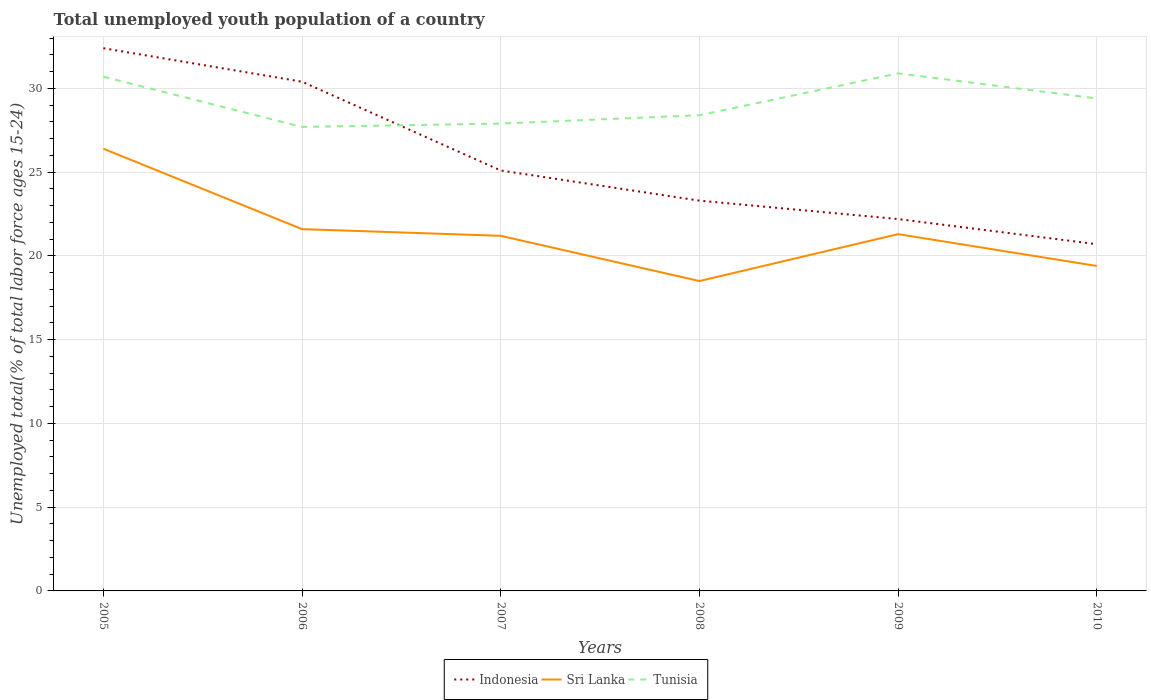Is the number of lines equal to the number of legend labels?
Offer a terse response. Yes. Across all years, what is the maximum percentage of total unemployed youth population of a country in Indonesia?
Keep it short and to the point. 20.7. In which year was the percentage of total unemployed youth population of a country in Sri Lanka maximum?
Offer a very short reply. 2008. What is the total percentage of total unemployed youth population of a country in Sri Lanka in the graph?
Give a very brief answer. 1.9. What is the difference between the highest and the second highest percentage of total unemployed youth population of a country in Sri Lanka?
Your response must be concise. 7.9. What is the difference between the highest and the lowest percentage of total unemployed youth population of a country in Indonesia?
Your response must be concise. 2. How many years are there in the graph?
Provide a succinct answer. 6. Are the values on the major ticks of Y-axis written in scientific E-notation?
Your answer should be compact. No. Does the graph contain any zero values?
Make the answer very short. No. Does the graph contain grids?
Provide a short and direct response. Yes. How many legend labels are there?
Your answer should be very brief. 3. How are the legend labels stacked?
Make the answer very short. Horizontal. What is the title of the graph?
Your response must be concise. Total unemployed youth population of a country. What is the label or title of the X-axis?
Make the answer very short. Years. What is the label or title of the Y-axis?
Your answer should be compact. Unemployed total(% of total labor force ages 15-24). What is the Unemployed total(% of total labor force ages 15-24) of Indonesia in 2005?
Make the answer very short. 32.4. What is the Unemployed total(% of total labor force ages 15-24) in Sri Lanka in 2005?
Give a very brief answer. 26.4. What is the Unemployed total(% of total labor force ages 15-24) in Tunisia in 2005?
Offer a terse response. 30.7. What is the Unemployed total(% of total labor force ages 15-24) in Indonesia in 2006?
Offer a terse response. 30.4. What is the Unemployed total(% of total labor force ages 15-24) in Sri Lanka in 2006?
Provide a succinct answer. 21.6. What is the Unemployed total(% of total labor force ages 15-24) in Tunisia in 2006?
Make the answer very short. 27.7. What is the Unemployed total(% of total labor force ages 15-24) in Indonesia in 2007?
Offer a terse response. 25.1. What is the Unemployed total(% of total labor force ages 15-24) of Sri Lanka in 2007?
Provide a succinct answer. 21.2. What is the Unemployed total(% of total labor force ages 15-24) in Tunisia in 2007?
Your answer should be very brief. 27.9. What is the Unemployed total(% of total labor force ages 15-24) in Indonesia in 2008?
Offer a very short reply. 23.3. What is the Unemployed total(% of total labor force ages 15-24) in Sri Lanka in 2008?
Make the answer very short. 18.5. What is the Unemployed total(% of total labor force ages 15-24) in Tunisia in 2008?
Give a very brief answer. 28.4. What is the Unemployed total(% of total labor force ages 15-24) of Indonesia in 2009?
Give a very brief answer. 22.2. What is the Unemployed total(% of total labor force ages 15-24) of Sri Lanka in 2009?
Make the answer very short. 21.3. What is the Unemployed total(% of total labor force ages 15-24) of Tunisia in 2009?
Offer a terse response. 30.9. What is the Unemployed total(% of total labor force ages 15-24) of Indonesia in 2010?
Your answer should be compact. 20.7. What is the Unemployed total(% of total labor force ages 15-24) in Sri Lanka in 2010?
Offer a very short reply. 19.4. What is the Unemployed total(% of total labor force ages 15-24) in Tunisia in 2010?
Give a very brief answer. 29.4. Across all years, what is the maximum Unemployed total(% of total labor force ages 15-24) of Indonesia?
Provide a succinct answer. 32.4. Across all years, what is the maximum Unemployed total(% of total labor force ages 15-24) of Sri Lanka?
Your response must be concise. 26.4. Across all years, what is the maximum Unemployed total(% of total labor force ages 15-24) in Tunisia?
Offer a terse response. 30.9. Across all years, what is the minimum Unemployed total(% of total labor force ages 15-24) of Indonesia?
Make the answer very short. 20.7. Across all years, what is the minimum Unemployed total(% of total labor force ages 15-24) in Sri Lanka?
Keep it short and to the point. 18.5. Across all years, what is the minimum Unemployed total(% of total labor force ages 15-24) in Tunisia?
Your answer should be very brief. 27.7. What is the total Unemployed total(% of total labor force ages 15-24) in Indonesia in the graph?
Ensure brevity in your answer.  154.1. What is the total Unemployed total(% of total labor force ages 15-24) in Sri Lanka in the graph?
Your answer should be compact. 128.4. What is the total Unemployed total(% of total labor force ages 15-24) in Tunisia in the graph?
Your response must be concise. 175. What is the difference between the Unemployed total(% of total labor force ages 15-24) in Sri Lanka in 2005 and that in 2006?
Your answer should be very brief. 4.8. What is the difference between the Unemployed total(% of total labor force ages 15-24) of Tunisia in 2005 and that in 2006?
Your answer should be compact. 3. What is the difference between the Unemployed total(% of total labor force ages 15-24) of Indonesia in 2005 and that in 2007?
Offer a terse response. 7.3. What is the difference between the Unemployed total(% of total labor force ages 15-24) of Indonesia in 2005 and that in 2008?
Keep it short and to the point. 9.1. What is the difference between the Unemployed total(% of total labor force ages 15-24) of Tunisia in 2005 and that in 2008?
Keep it short and to the point. 2.3. What is the difference between the Unemployed total(% of total labor force ages 15-24) of Sri Lanka in 2005 and that in 2009?
Offer a very short reply. 5.1. What is the difference between the Unemployed total(% of total labor force ages 15-24) in Indonesia in 2005 and that in 2010?
Keep it short and to the point. 11.7. What is the difference between the Unemployed total(% of total labor force ages 15-24) in Sri Lanka in 2005 and that in 2010?
Offer a very short reply. 7. What is the difference between the Unemployed total(% of total labor force ages 15-24) of Tunisia in 2005 and that in 2010?
Your answer should be compact. 1.3. What is the difference between the Unemployed total(% of total labor force ages 15-24) of Indonesia in 2006 and that in 2007?
Offer a very short reply. 5.3. What is the difference between the Unemployed total(% of total labor force ages 15-24) in Indonesia in 2006 and that in 2008?
Ensure brevity in your answer.  7.1. What is the difference between the Unemployed total(% of total labor force ages 15-24) in Tunisia in 2006 and that in 2009?
Give a very brief answer. -3.2. What is the difference between the Unemployed total(% of total labor force ages 15-24) in Sri Lanka in 2007 and that in 2008?
Make the answer very short. 2.7. What is the difference between the Unemployed total(% of total labor force ages 15-24) in Tunisia in 2007 and that in 2008?
Make the answer very short. -0.5. What is the difference between the Unemployed total(% of total labor force ages 15-24) in Indonesia in 2007 and that in 2009?
Your answer should be compact. 2.9. What is the difference between the Unemployed total(% of total labor force ages 15-24) of Sri Lanka in 2007 and that in 2009?
Give a very brief answer. -0.1. What is the difference between the Unemployed total(% of total labor force ages 15-24) in Tunisia in 2007 and that in 2010?
Give a very brief answer. -1.5. What is the difference between the Unemployed total(% of total labor force ages 15-24) of Sri Lanka in 2008 and that in 2009?
Keep it short and to the point. -2.8. What is the difference between the Unemployed total(% of total labor force ages 15-24) in Tunisia in 2008 and that in 2009?
Your answer should be very brief. -2.5. What is the difference between the Unemployed total(% of total labor force ages 15-24) of Indonesia in 2008 and that in 2010?
Offer a very short reply. 2.6. What is the difference between the Unemployed total(% of total labor force ages 15-24) in Tunisia in 2008 and that in 2010?
Your answer should be very brief. -1. What is the difference between the Unemployed total(% of total labor force ages 15-24) in Indonesia in 2009 and that in 2010?
Your response must be concise. 1.5. What is the difference between the Unemployed total(% of total labor force ages 15-24) of Indonesia in 2005 and the Unemployed total(% of total labor force ages 15-24) of Sri Lanka in 2006?
Provide a succinct answer. 10.8. What is the difference between the Unemployed total(% of total labor force ages 15-24) in Indonesia in 2005 and the Unemployed total(% of total labor force ages 15-24) in Tunisia in 2006?
Keep it short and to the point. 4.7. What is the difference between the Unemployed total(% of total labor force ages 15-24) in Indonesia in 2005 and the Unemployed total(% of total labor force ages 15-24) in Tunisia in 2007?
Provide a short and direct response. 4.5. What is the difference between the Unemployed total(% of total labor force ages 15-24) of Indonesia in 2005 and the Unemployed total(% of total labor force ages 15-24) of Tunisia in 2009?
Provide a short and direct response. 1.5. What is the difference between the Unemployed total(% of total labor force ages 15-24) in Sri Lanka in 2005 and the Unemployed total(% of total labor force ages 15-24) in Tunisia in 2010?
Your answer should be compact. -3. What is the difference between the Unemployed total(% of total labor force ages 15-24) in Indonesia in 2006 and the Unemployed total(% of total labor force ages 15-24) in Sri Lanka in 2007?
Provide a short and direct response. 9.2. What is the difference between the Unemployed total(% of total labor force ages 15-24) in Indonesia in 2006 and the Unemployed total(% of total labor force ages 15-24) in Sri Lanka in 2008?
Ensure brevity in your answer.  11.9. What is the difference between the Unemployed total(% of total labor force ages 15-24) of Sri Lanka in 2006 and the Unemployed total(% of total labor force ages 15-24) of Tunisia in 2008?
Make the answer very short. -6.8. What is the difference between the Unemployed total(% of total labor force ages 15-24) in Indonesia in 2006 and the Unemployed total(% of total labor force ages 15-24) in Sri Lanka in 2009?
Make the answer very short. 9.1. What is the difference between the Unemployed total(% of total labor force ages 15-24) in Indonesia in 2006 and the Unemployed total(% of total labor force ages 15-24) in Tunisia in 2009?
Your answer should be very brief. -0.5. What is the difference between the Unemployed total(% of total labor force ages 15-24) in Indonesia in 2006 and the Unemployed total(% of total labor force ages 15-24) in Sri Lanka in 2010?
Make the answer very short. 11. What is the difference between the Unemployed total(% of total labor force ages 15-24) of Indonesia in 2007 and the Unemployed total(% of total labor force ages 15-24) of Sri Lanka in 2008?
Your response must be concise. 6.6. What is the difference between the Unemployed total(% of total labor force ages 15-24) in Indonesia in 2007 and the Unemployed total(% of total labor force ages 15-24) in Tunisia in 2008?
Give a very brief answer. -3.3. What is the difference between the Unemployed total(% of total labor force ages 15-24) in Sri Lanka in 2007 and the Unemployed total(% of total labor force ages 15-24) in Tunisia in 2008?
Offer a very short reply. -7.2. What is the difference between the Unemployed total(% of total labor force ages 15-24) of Indonesia in 2007 and the Unemployed total(% of total labor force ages 15-24) of Tunisia in 2009?
Give a very brief answer. -5.8. What is the difference between the Unemployed total(% of total labor force ages 15-24) of Sri Lanka in 2007 and the Unemployed total(% of total labor force ages 15-24) of Tunisia in 2009?
Give a very brief answer. -9.7. What is the difference between the Unemployed total(% of total labor force ages 15-24) of Indonesia in 2007 and the Unemployed total(% of total labor force ages 15-24) of Sri Lanka in 2010?
Your answer should be very brief. 5.7. What is the difference between the Unemployed total(% of total labor force ages 15-24) in Indonesia in 2007 and the Unemployed total(% of total labor force ages 15-24) in Tunisia in 2010?
Keep it short and to the point. -4.3. What is the difference between the Unemployed total(% of total labor force ages 15-24) of Sri Lanka in 2007 and the Unemployed total(% of total labor force ages 15-24) of Tunisia in 2010?
Provide a short and direct response. -8.2. What is the difference between the Unemployed total(% of total labor force ages 15-24) of Indonesia in 2008 and the Unemployed total(% of total labor force ages 15-24) of Tunisia in 2009?
Provide a short and direct response. -7.6. What is the difference between the Unemployed total(% of total labor force ages 15-24) in Sri Lanka in 2008 and the Unemployed total(% of total labor force ages 15-24) in Tunisia in 2009?
Ensure brevity in your answer.  -12.4. What is the difference between the Unemployed total(% of total labor force ages 15-24) in Indonesia in 2008 and the Unemployed total(% of total labor force ages 15-24) in Sri Lanka in 2010?
Your answer should be compact. 3.9. What is the difference between the Unemployed total(% of total labor force ages 15-24) of Indonesia in 2008 and the Unemployed total(% of total labor force ages 15-24) of Tunisia in 2010?
Your answer should be very brief. -6.1. What is the difference between the Unemployed total(% of total labor force ages 15-24) in Indonesia in 2009 and the Unemployed total(% of total labor force ages 15-24) in Tunisia in 2010?
Your answer should be very brief. -7.2. What is the difference between the Unemployed total(% of total labor force ages 15-24) in Sri Lanka in 2009 and the Unemployed total(% of total labor force ages 15-24) in Tunisia in 2010?
Keep it short and to the point. -8.1. What is the average Unemployed total(% of total labor force ages 15-24) in Indonesia per year?
Ensure brevity in your answer.  25.68. What is the average Unemployed total(% of total labor force ages 15-24) of Sri Lanka per year?
Provide a short and direct response. 21.4. What is the average Unemployed total(% of total labor force ages 15-24) of Tunisia per year?
Your response must be concise. 29.17. In the year 2005, what is the difference between the Unemployed total(% of total labor force ages 15-24) of Indonesia and Unemployed total(% of total labor force ages 15-24) of Sri Lanka?
Provide a succinct answer. 6. In the year 2005, what is the difference between the Unemployed total(% of total labor force ages 15-24) in Indonesia and Unemployed total(% of total labor force ages 15-24) in Tunisia?
Your answer should be very brief. 1.7. In the year 2006, what is the difference between the Unemployed total(% of total labor force ages 15-24) in Indonesia and Unemployed total(% of total labor force ages 15-24) in Sri Lanka?
Your response must be concise. 8.8. In the year 2007, what is the difference between the Unemployed total(% of total labor force ages 15-24) in Indonesia and Unemployed total(% of total labor force ages 15-24) in Tunisia?
Provide a short and direct response. -2.8. In the year 2008, what is the difference between the Unemployed total(% of total labor force ages 15-24) in Indonesia and Unemployed total(% of total labor force ages 15-24) in Sri Lanka?
Your response must be concise. 4.8. In the year 2008, what is the difference between the Unemployed total(% of total labor force ages 15-24) of Indonesia and Unemployed total(% of total labor force ages 15-24) of Tunisia?
Keep it short and to the point. -5.1. In the year 2009, what is the difference between the Unemployed total(% of total labor force ages 15-24) in Indonesia and Unemployed total(% of total labor force ages 15-24) in Sri Lanka?
Keep it short and to the point. 0.9. In the year 2010, what is the difference between the Unemployed total(% of total labor force ages 15-24) of Indonesia and Unemployed total(% of total labor force ages 15-24) of Sri Lanka?
Give a very brief answer. 1.3. In the year 2010, what is the difference between the Unemployed total(% of total labor force ages 15-24) in Sri Lanka and Unemployed total(% of total labor force ages 15-24) in Tunisia?
Provide a succinct answer. -10. What is the ratio of the Unemployed total(% of total labor force ages 15-24) of Indonesia in 2005 to that in 2006?
Your answer should be very brief. 1.07. What is the ratio of the Unemployed total(% of total labor force ages 15-24) in Sri Lanka in 2005 to that in 2006?
Provide a short and direct response. 1.22. What is the ratio of the Unemployed total(% of total labor force ages 15-24) in Tunisia in 2005 to that in 2006?
Keep it short and to the point. 1.11. What is the ratio of the Unemployed total(% of total labor force ages 15-24) of Indonesia in 2005 to that in 2007?
Offer a very short reply. 1.29. What is the ratio of the Unemployed total(% of total labor force ages 15-24) of Sri Lanka in 2005 to that in 2007?
Give a very brief answer. 1.25. What is the ratio of the Unemployed total(% of total labor force ages 15-24) in Tunisia in 2005 to that in 2007?
Your answer should be very brief. 1.1. What is the ratio of the Unemployed total(% of total labor force ages 15-24) of Indonesia in 2005 to that in 2008?
Your answer should be very brief. 1.39. What is the ratio of the Unemployed total(% of total labor force ages 15-24) of Sri Lanka in 2005 to that in 2008?
Your response must be concise. 1.43. What is the ratio of the Unemployed total(% of total labor force ages 15-24) in Tunisia in 2005 to that in 2008?
Offer a very short reply. 1.08. What is the ratio of the Unemployed total(% of total labor force ages 15-24) of Indonesia in 2005 to that in 2009?
Offer a very short reply. 1.46. What is the ratio of the Unemployed total(% of total labor force ages 15-24) in Sri Lanka in 2005 to that in 2009?
Your answer should be compact. 1.24. What is the ratio of the Unemployed total(% of total labor force ages 15-24) of Indonesia in 2005 to that in 2010?
Provide a short and direct response. 1.57. What is the ratio of the Unemployed total(% of total labor force ages 15-24) of Sri Lanka in 2005 to that in 2010?
Keep it short and to the point. 1.36. What is the ratio of the Unemployed total(% of total labor force ages 15-24) of Tunisia in 2005 to that in 2010?
Make the answer very short. 1.04. What is the ratio of the Unemployed total(% of total labor force ages 15-24) in Indonesia in 2006 to that in 2007?
Ensure brevity in your answer.  1.21. What is the ratio of the Unemployed total(% of total labor force ages 15-24) of Sri Lanka in 2006 to that in 2007?
Make the answer very short. 1.02. What is the ratio of the Unemployed total(% of total labor force ages 15-24) in Indonesia in 2006 to that in 2008?
Provide a short and direct response. 1.3. What is the ratio of the Unemployed total(% of total labor force ages 15-24) of Sri Lanka in 2006 to that in 2008?
Offer a very short reply. 1.17. What is the ratio of the Unemployed total(% of total labor force ages 15-24) of Tunisia in 2006 to that in 2008?
Offer a terse response. 0.98. What is the ratio of the Unemployed total(% of total labor force ages 15-24) in Indonesia in 2006 to that in 2009?
Your answer should be very brief. 1.37. What is the ratio of the Unemployed total(% of total labor force ages 15-24) of Sri Lanka in 2006 to that in 2009?
Make the answer very short. 1.01. What is the ratio of the Unemployed total(% of total labor force ages 15-24) of Tunisia in 2006 to that in 2009?
Your answer should be compact. 0.9. What is the ratio of the Unemployed total(% of total labor force ages 15-24) in Indonesia in 2006 to that in 2010?
Provide a succinct answer. 1.47. What is the ratio of the Unemployed total(% of total labor force ages 15-24) of Sri Lanka in 2006 to that in 2010?
Offer a terse response. 1.11. What is the ratio of the Unemployed total(% of total labor force ages 15-24) of Tunisia in 2006 to that in 2010?
Offer a terse response. 0.94. What is the ratio of the Unemployed total(% of total labor force ages 15-24) of Indonesia in 2007 to that in 2008?
Make the answer very short. 1.08. What is the ratio of the Unemployed total(% of total labor force ages 15-24) in Sri Lanka in 2007 to that in 2008?
Make the answer very short. 1.15. What is the ratio of the Unemployed total(% of total labor force ages 15-24) in Tunisia in 2007 to that in 2008?
Ensure brevity in your answer.  0.98. What is the ratio of the Unemployed total(% of total labor force ages 15-24) of Indonesia in 2007 to that in 2009?
Keep it short and to the point. 1.13. What is the ratio of the Unemployed total(% of total labor force ages 15-24) in Tunisia in 2007 to that in 2009?
Provide a short and direct response. 0.9. What is the ratio of the Unemployed total(% of total labor force ages 15-24) in Indonesia in 2007 to that in 2010?
Give a very brief answer. 1.21. What is the ratio of the Unemployed total(% of total labor force ages 15-24) in Sri Lanka in 2007 to that in 2010?
Your answer should be compact. 1.09. What is the ratio of the Unemployed total(% of total labor force ages 15-24) of Tunisia in 2007 to that in 2010?
Ensure brevity in your answer.  0.95. What is the ratio of the Unemployed total(% of total labor force ages 15-24) in Indonesia in 2008 to that in 2009?
Give a very brief answer. 1.05. What is the ratio of the Unemployed total(% of total labor force ages 15-24) of Sri Lanka in 2008 to that in 2009?
Provide a short and direct response. 0.87. What is the ratio of the Unemployed total(% of total labor force ages 15-24) of Tunisia in 2008 to that in 2009?
Make the answer very short. 0.92. What is the ratio of the Unemployed total(% of total labor force ages 15-24) in Indonesia in 2008 to that in 2010?
Make the answer very short. 1.13. What is the ratio of the Unemployed total(% of total labor force ages 15-24) of Sri Lanka in 2008 to that in 2010?
Your answer should be compact. 0.95. What is the ratio of the Unemployed total(% of total labor force ages 15-24) of Tunisia in 2008 to that in 2010?
Give a very brief answer. 0.97. What is the ratio of the Unemployed total(% of total labor force ages 15-24) of Indonesia in 2009 to that in 2010?
Make the answer very short. 1.07. What is the ratio of the Unemployed total(% of total labor force ages 15-24) in Sri Lanka in 2009 to that in 2010?
Your response must be concise. 1.1. What is the ratio of the Unemployed total(% of total labor force ages 15-24) of Tunisia in 2009 to that in 2010?
Provide a short and direct response. 1.05. What is the difference between the highest and the second highest Unemployed total(% of total labor force ages 15-24) in Indonesia?
Offer a terse response. 2. What is the difference between the highest and the second highest Unemployed total(% of total labor force ages 15-24) in Tunisia?
Provide a short and direct response. 0.2. What is the difference between the highest and the lowest Unemployed total(% of total labor force ages 15-24) in Indonesia?
Give a very brief answer. 11.7. What is the difference between the highest and the lowest Unemployed total(% of total labor force ages 15-24) in Tunisia?
Keep it short and to the point. 3.2. 